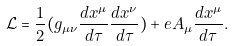<formula> <loc_0><loc_0><loc_500><loc_500>\mathcal { L } = \frac { 1 } { 2 } ( g _ { \mu \nu } \frac { d x ^ { \mu } } { d \tau } \frac { d x ^ { \nu } } { d \tau } ) + e A _ { \mu } \frac { d x ^ { \mu } } { d \tau } .</formula> 